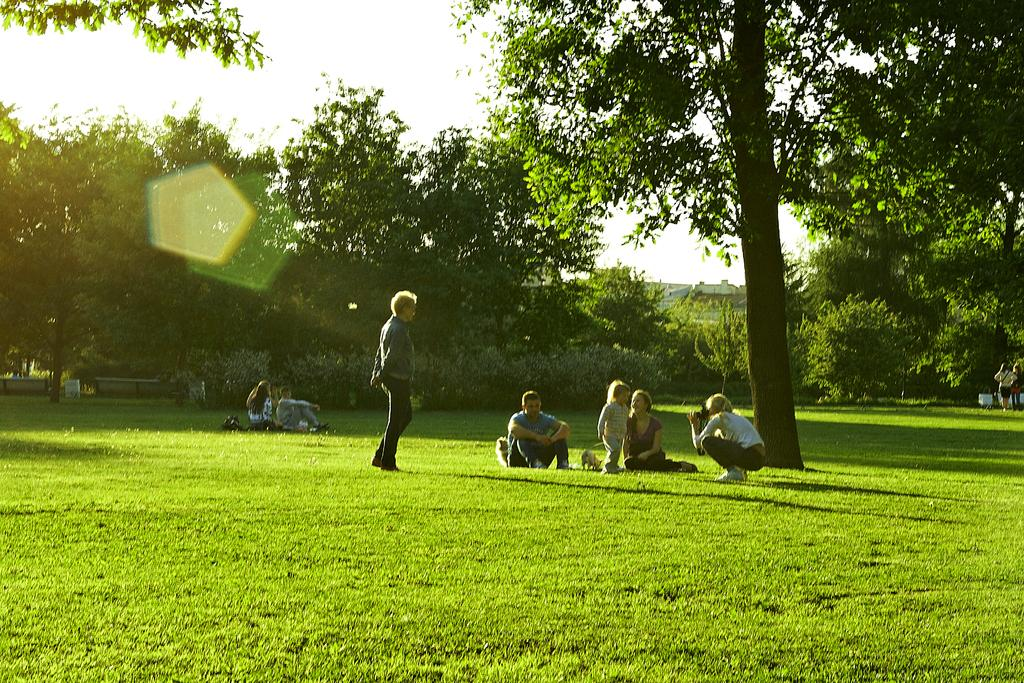What type of vegetation is present in the image? There is grass in the image. What are the people doing on the grass? The people are on the grass, but their specific activities are not mentioned in the facts. What else can be seen in the image besides the grass? There are trees visible in the image. What is visible in the background of the image? The sky is visible in the background of the image. What type of crayon is being used to draw on the grass in the image? There is no crayon or drawing activity present in the image. Can you see any frogs hopping around on the grass in the image? There is no mention of frogs in the image, so we cannot determine if any are present. 